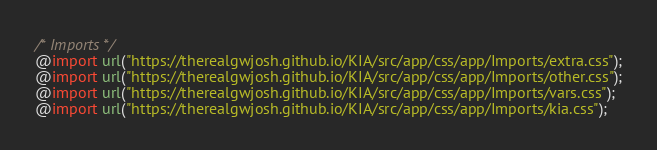Convert code to text. <code><loc_0><loc_0><loc_500><loc_500><_CSS_>/* Imports */
@import url("https://therealgwjosh.github.io/KIA/src/app/css/app/Imports/extra.css");
@import url("https://therealgwjosh.github.io/KIA/src/app/css/app/Imports/other.css");
@import url("https://therealgwjosh.github.io/KIA/src/app/css/app/Imports/vars.css");
@import url("https://therealgwjosh.github.io/KIA/src/app/css/app/Imports/kia.css");
</code> 